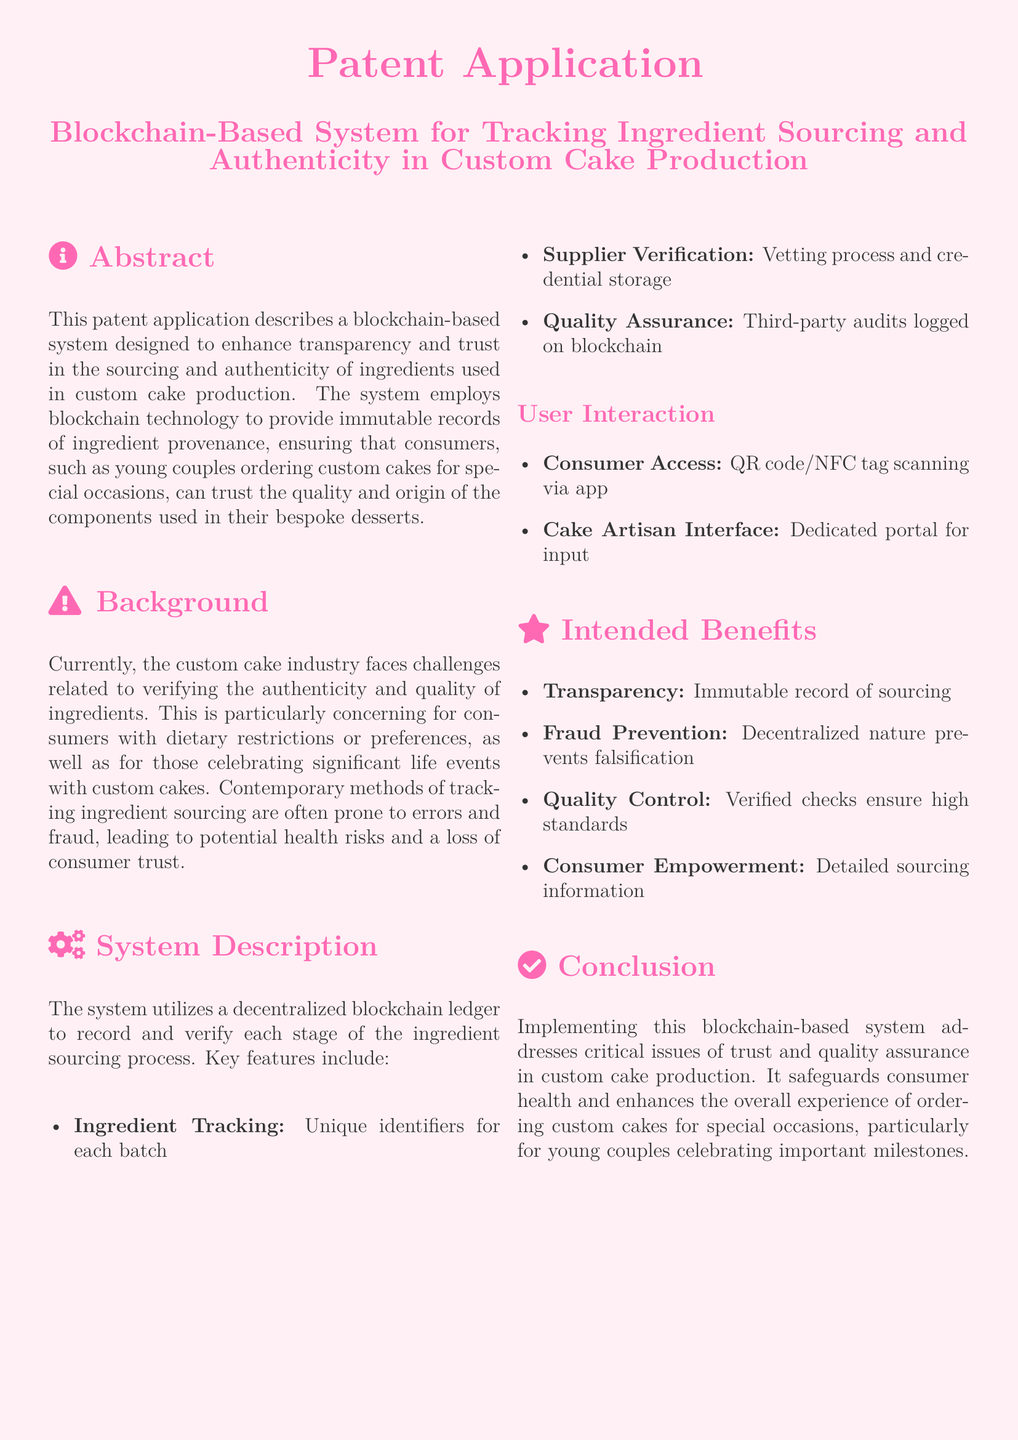What is the main topic of the patent application? The main topic of the patent application is related to tracking ingredient sourcing and authenticity in custom cake production using blockchain technology.
Answer: Blockchain-Based System for Tracking Ingredient Sourcing and Authenticity in Custom Cake Production What is one of the key features of the system? The document lists key features such as ingredient tracking, supplier verification, and quality assurance.
Answer: Ingredient Tracking Who is the intended consumer for this system? The document specifies who would benefit from the system, noting a specific demographic.
Answer: Young couples ordering custom cakes for special occasions What is one benefit mentioned in the system description? The document outlines several intended benefits of the system, which include various aspects of trust and quality control.
Answer: Transparency How does the consumer access the ingredient information? The document explains the consumer interaction method that enables access to ingredient sourcing details.
Answer: QR code/NFC tag scanning via app What problem does the system aim to address? The background section highlights specific challenges faced by the custom cake industry, focusing on a major concern.
Answer: Verifying the authenticity and quality of ingredients What is a method described for supplier verification? The document briefly mentions the means by which suppliers are verified in the application.
Answer: Vetting process and credential storage What auditing process is included in the system? The document states the type of checks conducted to ensure ingredient quality.
Answer: Third-party audits logged on blockchain 